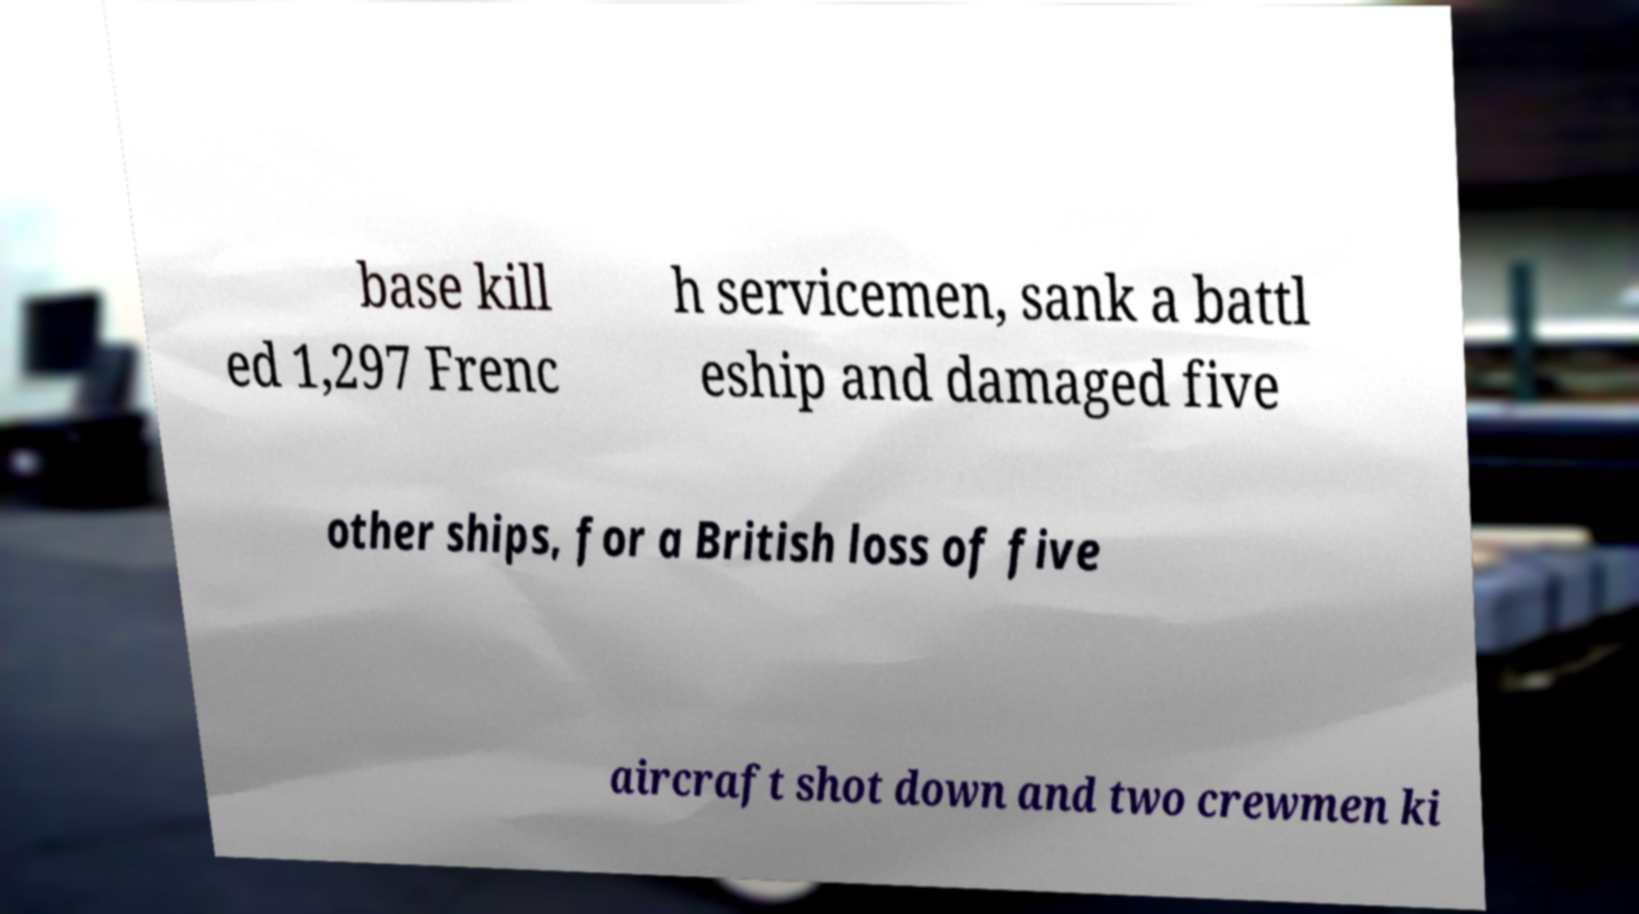Please read and relay the text visible in this image. What does it say? base kill ed 1,297 Frenc h servicemen, sank a battl eship and damaged five other ships, for a British loss of five aircraft shot down and two crewmen ki 